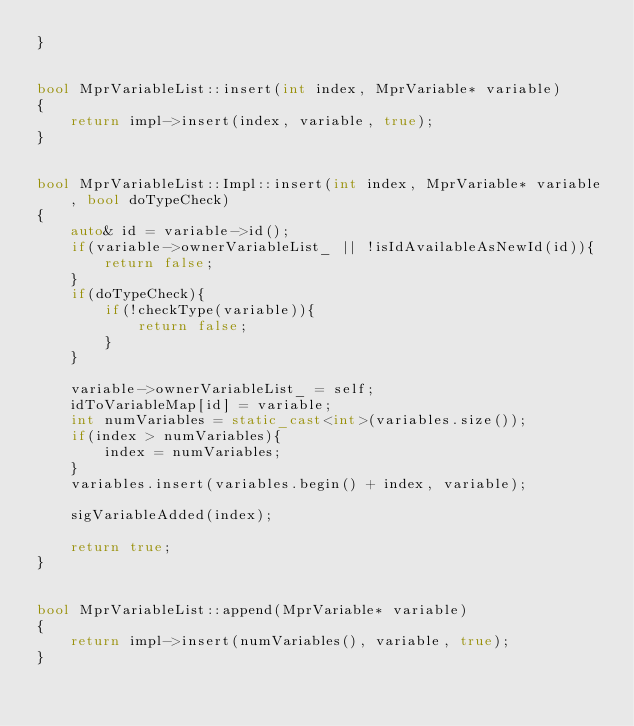<code> <loc_0><loc_0><loc_500><loc_500><_C++_>}


bool MprVariableList::insert(int index, MprVariable* variable)
{
    return impl->insert(index, variable, true);
}


bool MprVariableList::Impl::insert(int index, MprVariable* variable, bool doTypeCheck)
{
    auto& id = variable->id();
    if(variable->ownerVariableList_ || !isIdAvailableAsNewId(id)){
        return false;
    }
    if(doTypeCheck){
        if(!checkType(variable)){
            return false;
        }
    }
    
    variable->ownerVariableList_ = self;
    idToVariableMap[id] = variable;
    int numVariables = static_cast<int>(variables.size());
    if(index > numVariables){
        index = numVariables;
    }
    variables.insert(variables.begin() + index, variable);

    sigVariableAdded(index);
    
    return true;
}


bool MprVariableList::append(MprVariable* variable)
{
    return impl->insert(numVariables(), variable, true);
}

</code> 